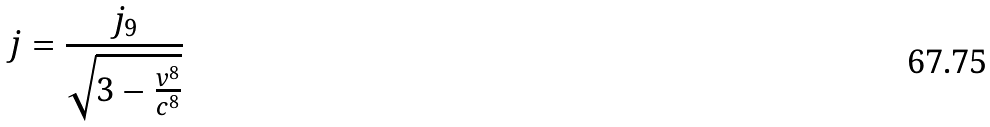<formula> <loc_0><loc_0><loc_500><loc_500>j = \frac { j _ { 9 } } { \sqrt { 3 - \frac { v ^ { 8 } } { c ^ { 8 } } } }</formula> 